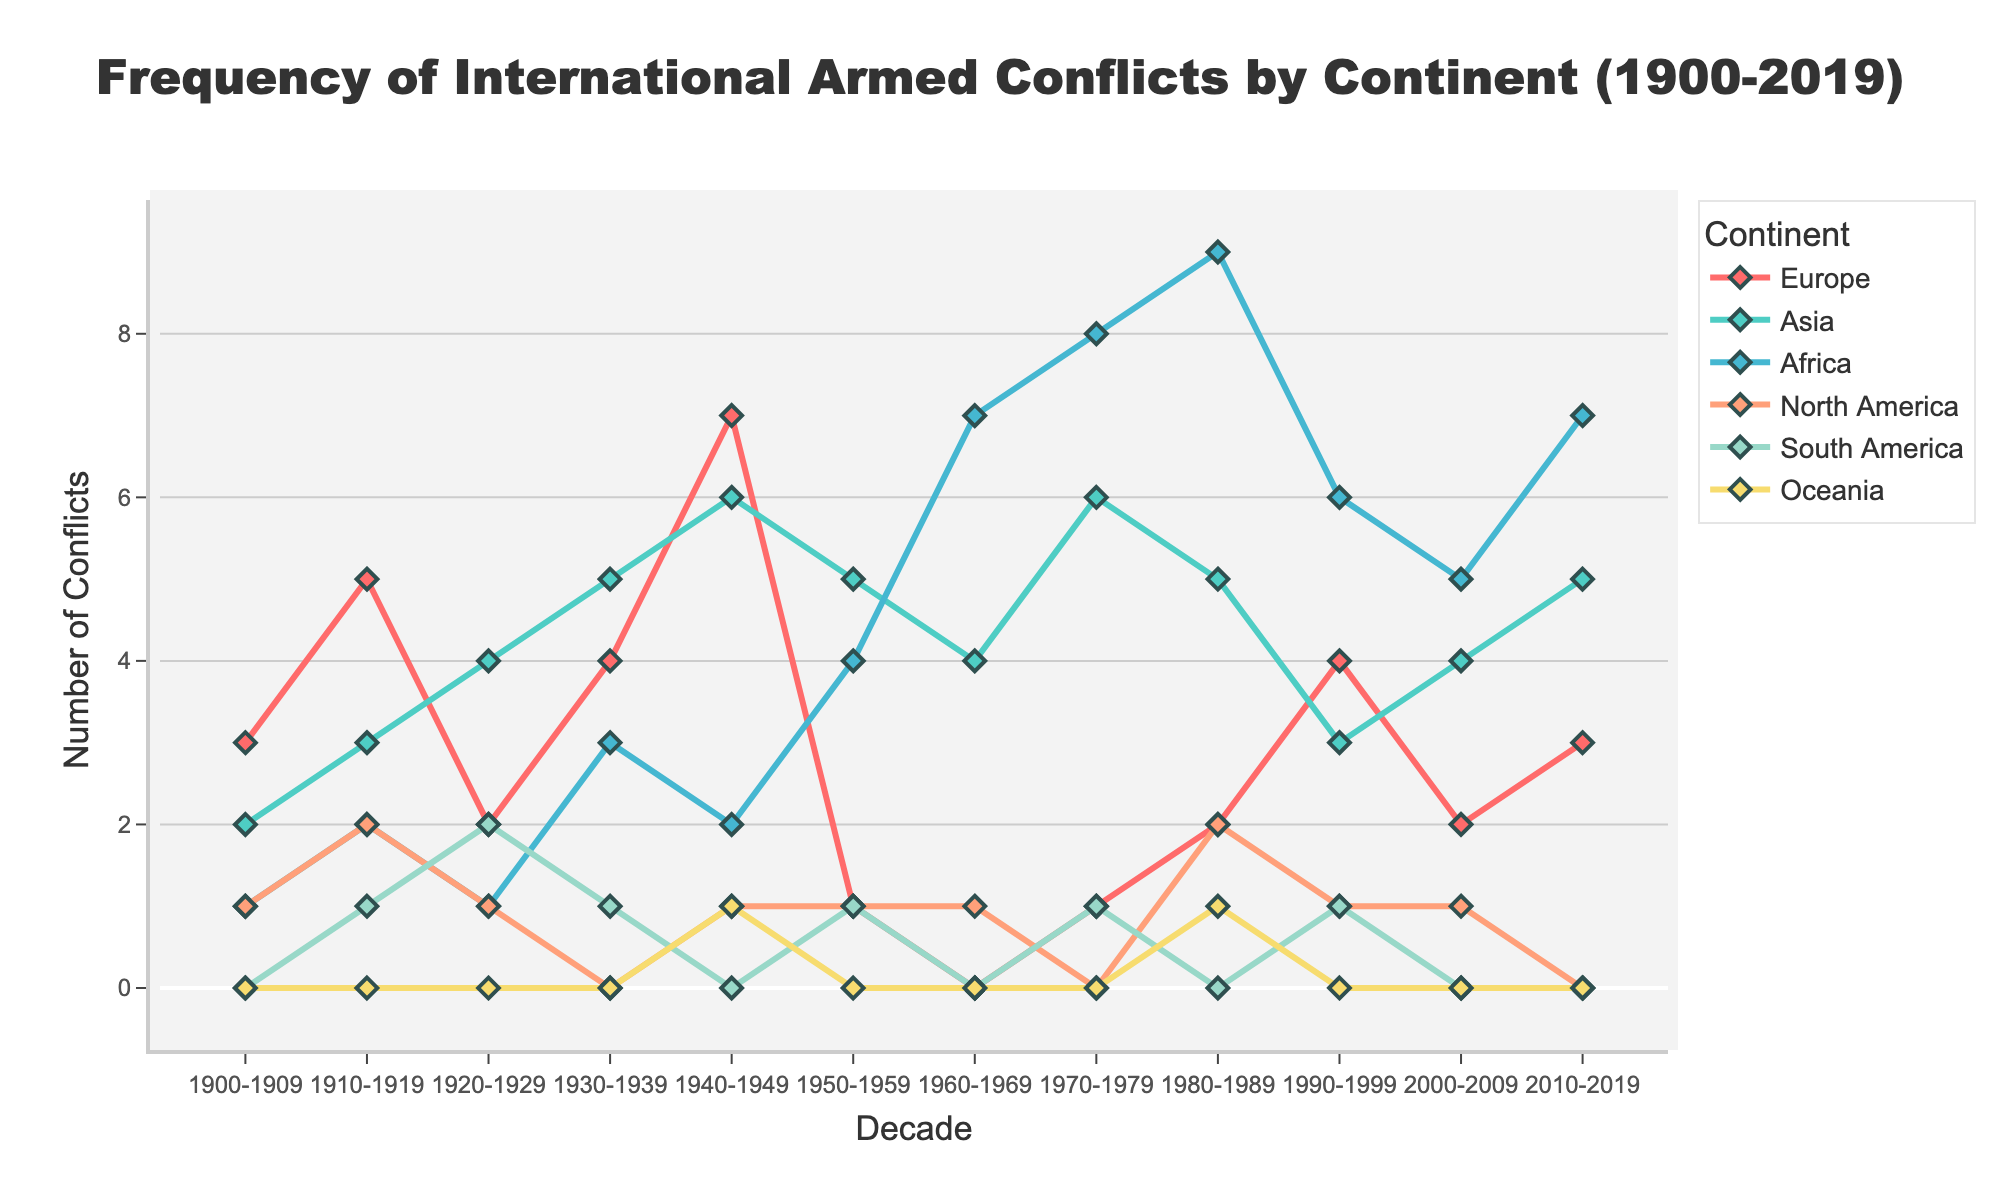Which continent had the highest number of international armed conflicts in the 1940s? Look at the data lines for each continent in the 1940-1949 decade. Europe has 7 conflicts, which is the highest among all the continents.
Answer: Europe Which continent experienced the most significant increase in conflicts from the 1900s to the 1910s? Examine the change in conflicts for each continent from the 1900-1909 decade to the 1910-1919 decade. Europe increased from 3 to 5 conflicts, while Asia increased from 2 to 3, Africa from 1 to 2, North America from 1 to 2, and South America from 0 to 1. Europe saw the largest increase, going from 3 to 5.
Answer: Europe What is the smallest number of conflicts in any decade for Oceania? Look at the visual line for Oceania across all decades. There are decades where Oceania has 0 conflicts. This is the smallest number.
Answer: 0 Which continent shows the highest number of conflicts in the 1980s? Check the height of the markers for each continent in the 1980-1989 decade. Africa shows the highest marker at 9 conflicts.
Answer: Africa How many conflicts did Europe experience in total during the 20th century? Sum the number of conflicts in Europe for the decades 1900-1909 to 1990-1999. Europe has 3 + 5 + 2 + 4 + 7 + 1 + 0 + 1 + 2 + 4 = 29 conflicts in total in the 20th century.
Answer: 29 Which decades did North America see zero conflicts? Look at the North America line to see where it hits zero. North America has zero conflicts in the 1930-1939, 1970-1979, and 2010-2019 decades.
Answer: 1930-1939, 1970-1979, 2010-2019 What is the average number of conflicts for Asia over the entire period? Sum the number of conflicts for Asia across all decades, then divide by the number of decades. Asia has 2 + 3 + 4 + 5 + 6 + 5 + 4 + 6 + 5 + 3 + 4 + 5 = 52 conflicts over 12 decades. The average is 52 / 12 ≈ 4.33.
Answer: 4.33 What were the two decades with the highest number of conflicts in Africa, and what were the conflict counts? Look at the peaks in the Africa line. The two highest points are in the 1980s and 1970s, with conflict counts of 9 and 8, respectively.
Answer: 1980s (9), 1970s (8) 